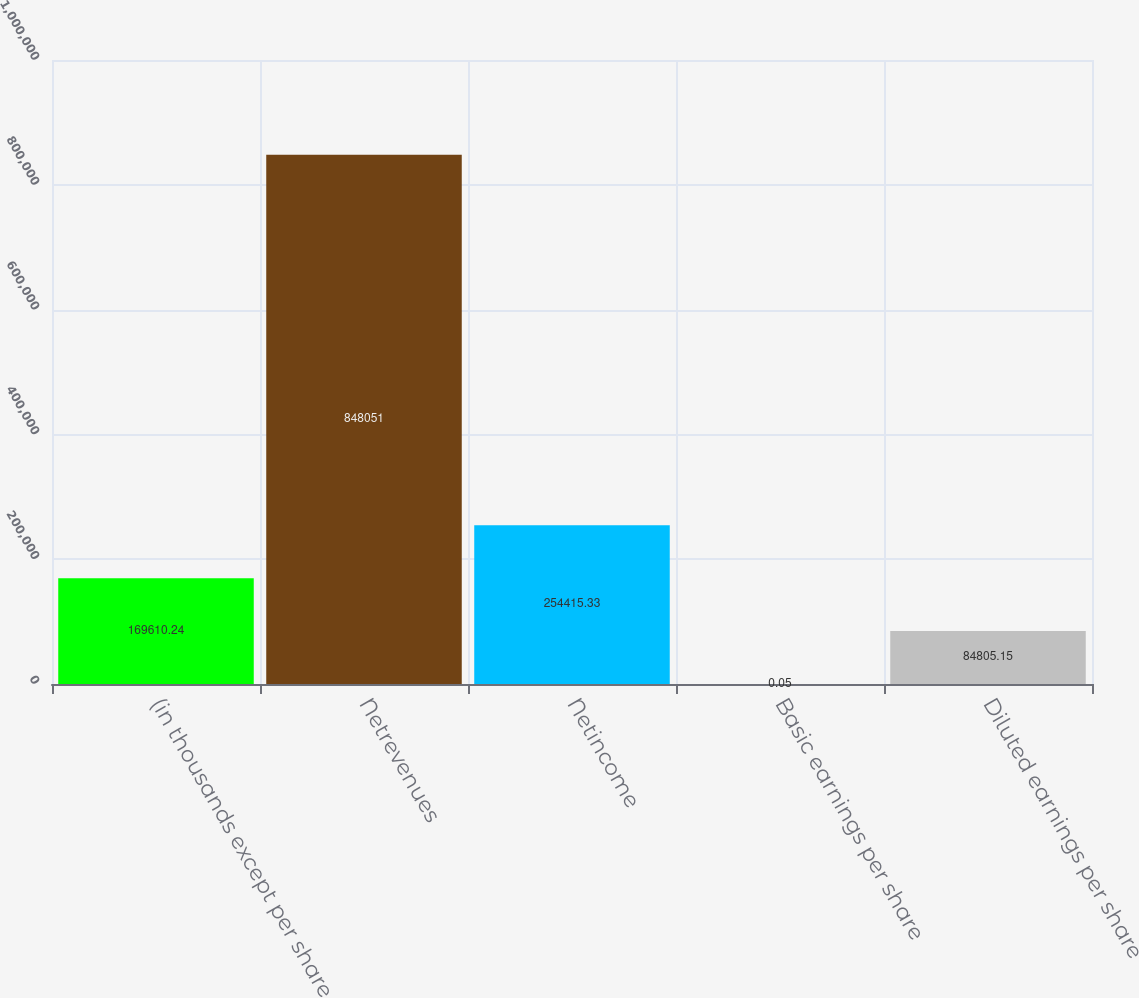Convert chart. <chart><loc_0><loc_0><loc_500><loc_500><bar_chart><fcel>(in thousands except per share<fcel>Netrevenues<fcel>Netincome<fcel>Basic earnings per share<fcel>Diluted earnings per share<nl><fcel>169610<fcel>848051<fcel>254415<fcel>0.05<fcel>84805.1<nl></chart> 